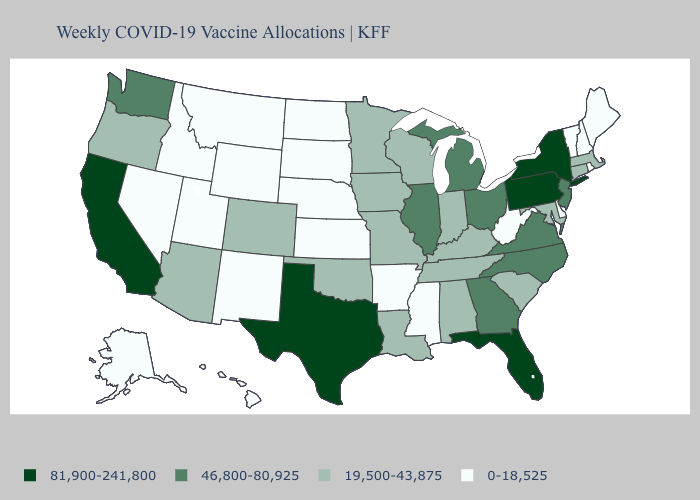Does the map have missing data?
Concise answer only. No. What is the highest value in the Northeast ?
Concise answer only. 81,900-241,800. Which states have the highest value in the USA?
Quick response, please. California, Florida, New York, Pennsylvania, Texas. Does West Virginia have the lowest value in the USA?
Keep it brief. Yes. What is the value of New Hampshire?
Concise answer only. 0-18,525. Does Idaho have the lowest value in the West?
Answer briefly. Yes. Among the states that border Massachusetts , does New York have the highest value?
Concise answer only. Yes. Name the states that have a value in the range 46,800-80,925?
Write a very short answer. Georgia, Illinois, Michigan, New Jersey, North Carolina, Ohio, Virginia, Washington. Name the states that have a value in the range 46,800-80,925?
Give a very brief answer. Georgia, Illinois, Michigan, New Jersey, North Carolina, Ohio, Virginia, Washington. Name the states that have a value in the range 19,500-43,875?
Short answer required. Alabama, Arizona, Colorado, Connecticut, Indiana, Iowa, Kentucky, Louisiana, Maryland, Massachusetts, Minnesota, Missouri, Oklahoma, Oregon, South Carolina, Tennessee, Wisconsin. Which states have the lowest value in the Northeast?
Answer briefly. Maine, New Hampshire, Rhode Island, Vermont. Name the states that have a value in the range 19,500-43,875?
Concise answer only. Alabama, Arizona, Colorado, Connecticut, Indiana, Iowa, Kentucky, Louisiana, Maryland, Massachusetts, Minnesota, Missouri, Oklahoma, Oregon, South Carolina, Tennessee, Wisconsin. Which states have the lowest value in the MidWest?
Write a very short answer. Kansas, Nebraska, North Dakota, South Dakota. What is the value of California?
Write a very short answer. 81,900-241,800. What is the highest value in the USA?
Give a very brief answer. 81,900-241,800. 